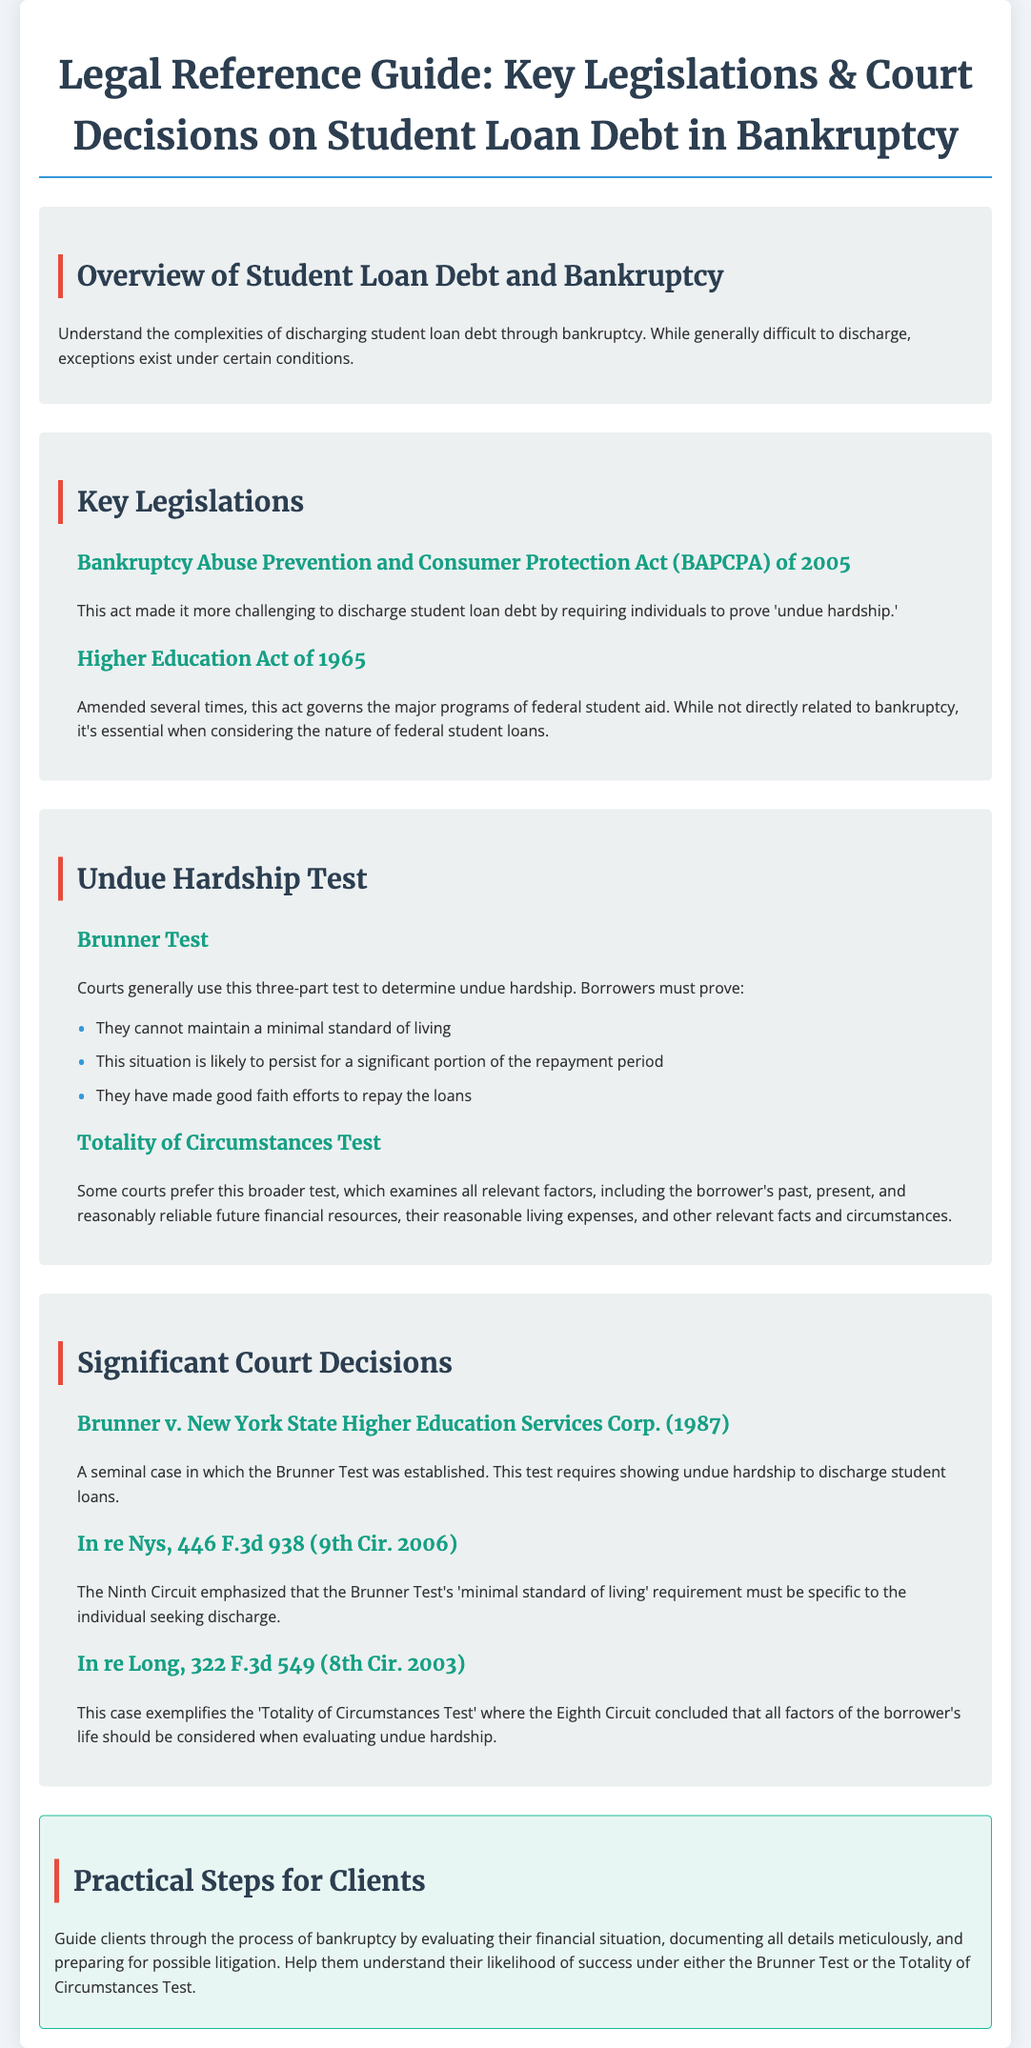What is the title of the document? The title is found at the top of the document, summarizing its content and focus.
Answer: Legal Reference Guide: Key Legislations & Court Decisions on Student Loan Debt in Bankruptcy What does the BAPCPA stand for? The abbreviation is explained in the section that describes the act's purpose.
Answer: Bankruptcy Abuse Prevention and Consumer Protection Act What is the primary requirement of the Brunner Test? The specific test requirement can be located in the description of the test under the undue hardship section.
Answer: Undue hardship Which act governs federal student aid programs? It is mentioned in the key legislations section as a significant act affecting student loans.
Answer: Higher Education Act of 1965 What year was the Brunner v. New York State Higher Education Services Corp. case? The case year is provided within the section discussing significant court decisions.
Answer: 1987 What is one key component of the Totality of Circumstances Test? This detail can be found in the subsection explaining this test.
Answer: All relevant factors What should clients prepare for in the bankruptcy process? This information comes from the practical steps for clients' section indicating a crucial aspect they must consider.
Answer: Possible litigation What does the document recommend for evaluating clients' situations? This is highlighted in the practical steps section.
Answer: Financial situation 